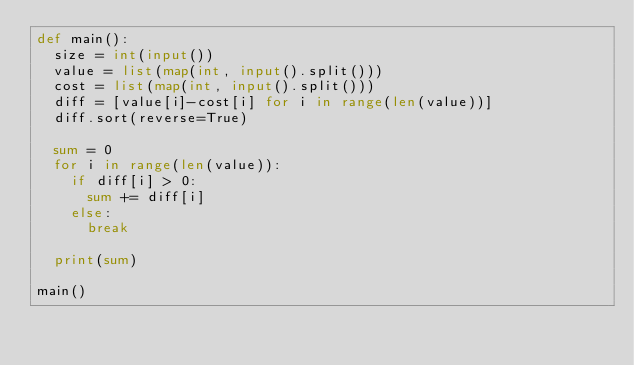Convert code to text. <code><loc_0><loc_0><loc_500><loc_500><_Python_>def main():
  size = int(input())
  value = list(map(int, input().split()))
  cost = list(map(int, input().split()))
  diff = [value[i]-cost[i] for i in range(len(value))]
  diff.sort(reverse=True)
              
  sum = 0
  for i in range(len(value)):
    if diff[i] > 0:
      sum += diff[i]
    else: 
      break
        
  print(sum)

main()
              </code> 